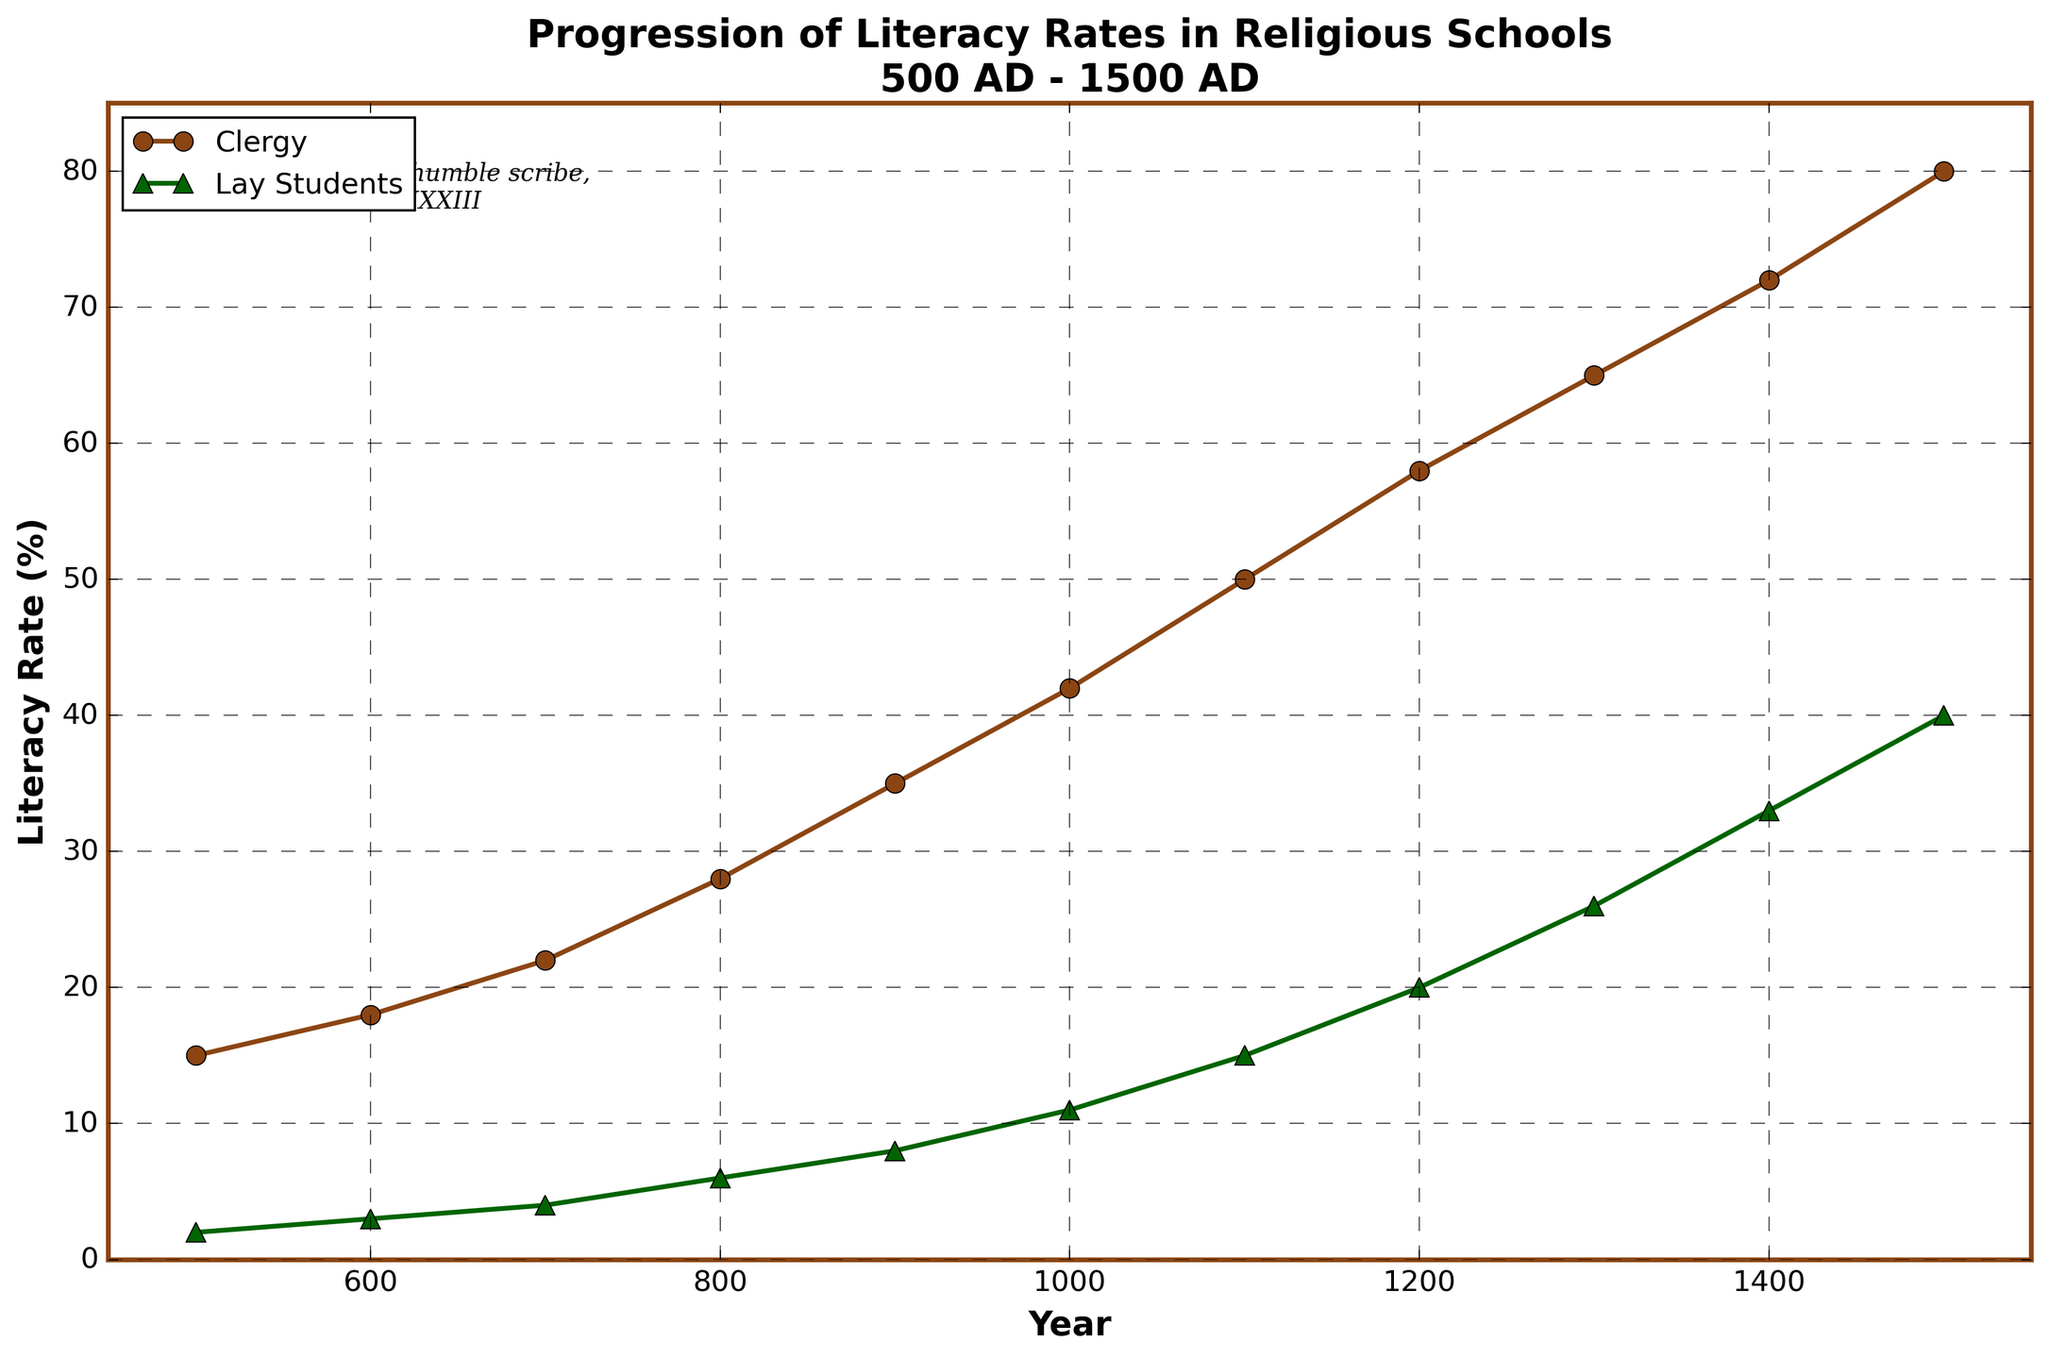what is the difference in literacy rates between the clergy and lay students in the year 1500? The literacy rate for clergy in 1500 is 80%, and for lay students, it is 40%. The difference is calculated as 80% - 40% = 40%.
Answer: 40% Which year had the smallest difference in literacy rates between clergy and lay students? By examining the chart, the smallest difference in literacy rates is in the year 500, where clergy literacy is 15% and lay students' literacy is 2%, a difference of 13%.
Answer: 500 How did the literacy rate for lay students change from 900 AD to 1000 AD? In 900 AD, the literacy rate for lay students was 8%. In 1000 AD, it was 11%. The change is calculated as 11% - 8% = 3%.
Answer: 3% Compare the growth rate of literacy rates for clergy and lay students between 700 AD and 800 AD. For clergy, the growth from 700 AD (22%) to 800 AD (28%) is 28% - 22% = 6%. For lay students, from 700 AD (4%) to 800 AD (6%) is 6% - 4% = 2%. Clergy literacy rates grew by 6%, while lay students' rates grew by 2%.
Answer: Clergy: 6%, Lay Students: 2% What can be observed about the trend of literacy rates for both groups over the centuries? The overall trend shows that both the literacy rates for clergy and lay students steadily increased from 500 AD to 1500 AD. The clergy's literacy rates were consistently higher throughout this period.
Answer: Steadily increasing What is the average literacy rate for clergy across the entire timeframe provided in the chart? Sum the literacy rates over the years for clergy: 15 + 18 + 22 + 28 + 35 + 42 + 50 + 58 + 65 + 72 + 80 = 485. There are 11 data points, so the average is 485 / 11 ≈ 44.09%.
Answer: 44.09% Determine the percentage point difference between clergy and lay students in the year 1300, and explain its significance. In 1300, the clergy's literacy rate was 65%, and lay students were at 26%. The difference is 65% - 26% = 39 percentage points. This indicates a significant disparity in education access between clergy and lay students.
Answer: 39 percentage points Which year shows the highest increase in literacy rates for lay students compared to the previous century? Examine the data to find the highest increase between consecutive centuries: 8% (900) to 11% (1000) = 3%, 11% (1000) to 15% (1100) = 4%, 15% (1100) to 20% (1200) = 5%, 20% (1200) to 26% (1300) = 6%, 26% (1300) to 33% (1400) = 7%, 33% (1400) to 40% (1500) = 7%. The highest increases are 7% between 1300-1400 and 1400-1500.
Answer: 1300-1400 and 1400-1500 What visual attributes distinguish the literacy rates of clergy and lay students in the figure? Clergy literacy rates are represented with circles connected by a brown line, while lay students' rates are represented with triangles connected by a green line.
Answer: Circles and brown vs. triangles and green Calculate the total increase in literacy rates for clergy from 500 AD to 1500 AD. The initial literacy rate for clergy in 500 AD was 15%, and it reached 80% in 1500 AD. The total increase is 80% - 15% = 65%.
Answer: 65% 